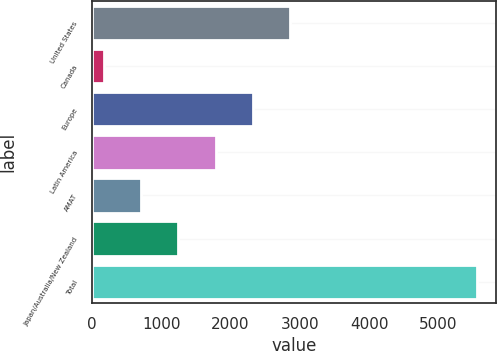Convert chart. <chart><loc_0><loc_0><loc_500><loc_500><bar_chart><fcel>United States<fcel>Canada<fcel>Europe<fcel>Latin America<fcel>AMAT<fcel>Japan/Australia/New Zealand<fcel>Total<nl><fcel>2861.75<fcel>172.6<fcel>2323.92<fcel>1786.09<fcel>710.43<fcel>1248.26<fcel>5550.9<nl></chart> 